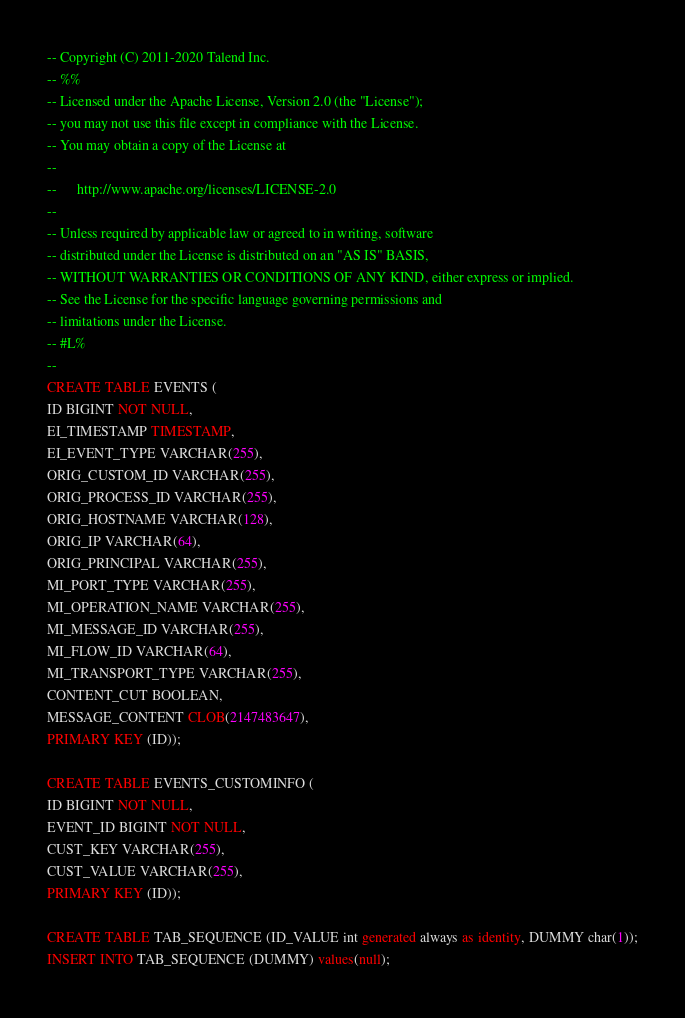Convert code to text. <code><loc_0><loc_0><loc_500><loc_500><_SQL_>-- Copyright (C) 2011-2020 Talend Inc.
-- %%
-- Licensed under the Apache License, Version 2.0 (the "License");
-- you may not use this file except in compliance with the License.
-- You may obtain a copy of the License at
--
--      http://www.apache.org/licenses/LICENSE-2.0
--
-- Unless required by applicable law or agreed to in writing, software
-- distributed under the License is distributed on an "AS IS" BASIS,
-- WITHOUT WARRANTIES OR CONDITIONS OF ANY KIND, either express or implied.
-- See the License for the specific language governing permissions and
-- limitations under the License.
-- #L%
--
CREATE TABLE EVENTS (
ID BIGINT NOT NULL,
EI_TIMESTAMP TIMESTAMP,
EI_EVENT_TYPE VARCHAR(255),
ORIG_CUSTOM_ID VARCHAR(255),
ORIG_PROCESS_ID VARCHAR(255),
ORIG_HOSTNAME VARCHAR(128),
ORIG_IP VARCHAR(64),
ORIG_PRINCIPAL VARCHAR(255),
MI_PORT_TYPE VARCHAR(255),
MI_OPERATION_NAME VARCHAR(255),
MI_MESSAGE_ID VARCHAR(255),
MI_FLOW_ID VARCHAR(64),
MI_TRANSPORT_TYPE VARCHAR(255),
CONTENT_CUT BOOLEAN,
MESSAGE_CONTENT CLOB(2147483647),
PRIMARY KEY (ID));

CREATE TABLE EVENTS_CUSTOMINFO (
ID BIGINT NOT NULL,
EVENT_ID BIGINT NOT NULL,
CUST_KEY VARCHAR(255),
CUST_VALUE VARCHAR(255),
PRIMARY KEY (ID));

CREATE TABLE TAB_SEQUENCE (ID_VALUE int generated always as identity, DUMMY char(1));
INSERT INTO TAB_SEQUENCE (DUMMY) values(null);</code> 